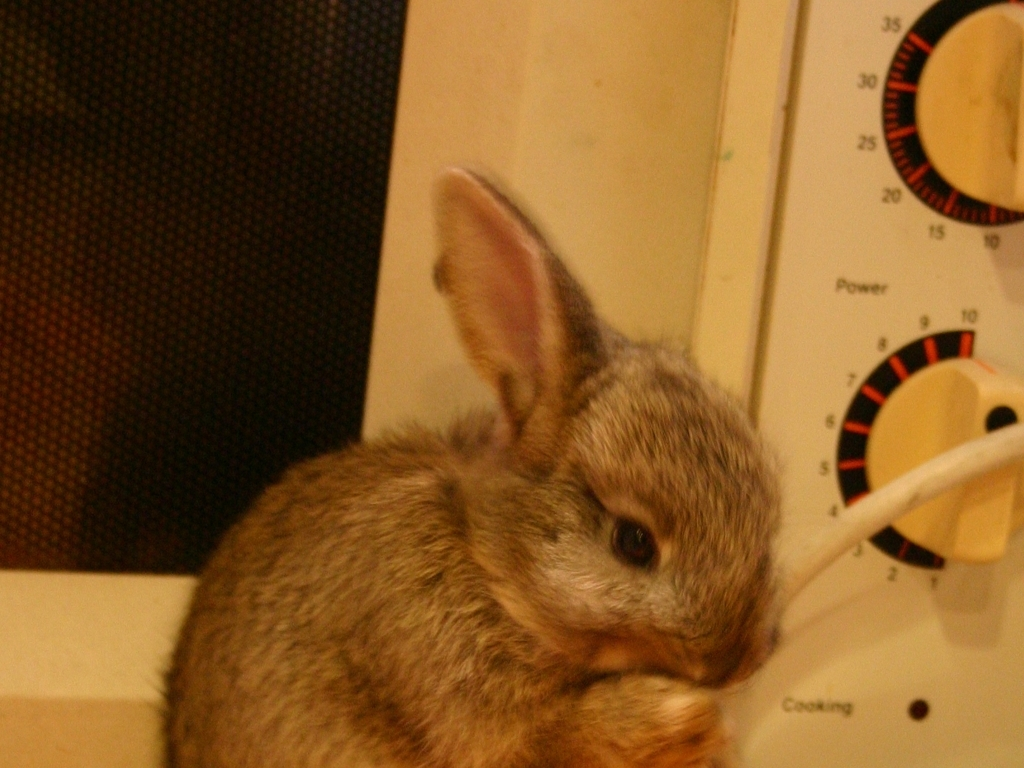Can you describe what the rabbit is doing? The rabbit appears to be curiously nibbling or sniffing at a cable, which suggests a natural exploratory behavior typical of small animals like rabbits, although it's not a safe activity for them due to the risk of electrical hazard. 